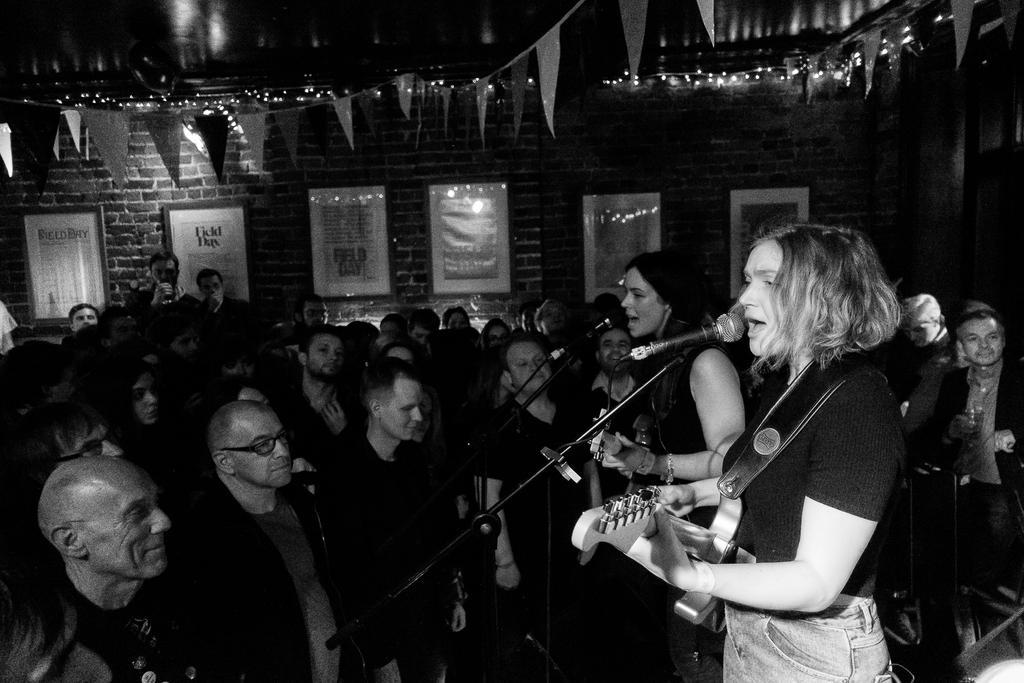In one or two sentences, can you explain what this image depicts? In this image we can see the people standing and there are two persons standing and singing in front of the microphones and playing musical instruments. And we can see the photo frames attached to the wall. At the top we can see the flags and serial lights. 